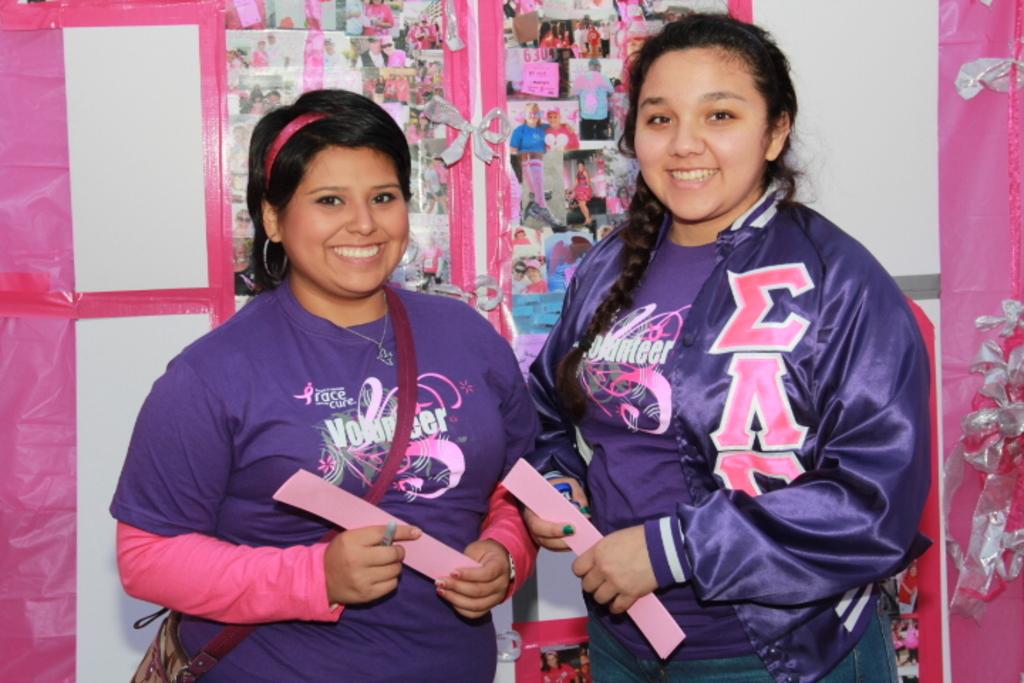What type of event are these women volunteering at?
Your answer should be compact. Race for the cure. 